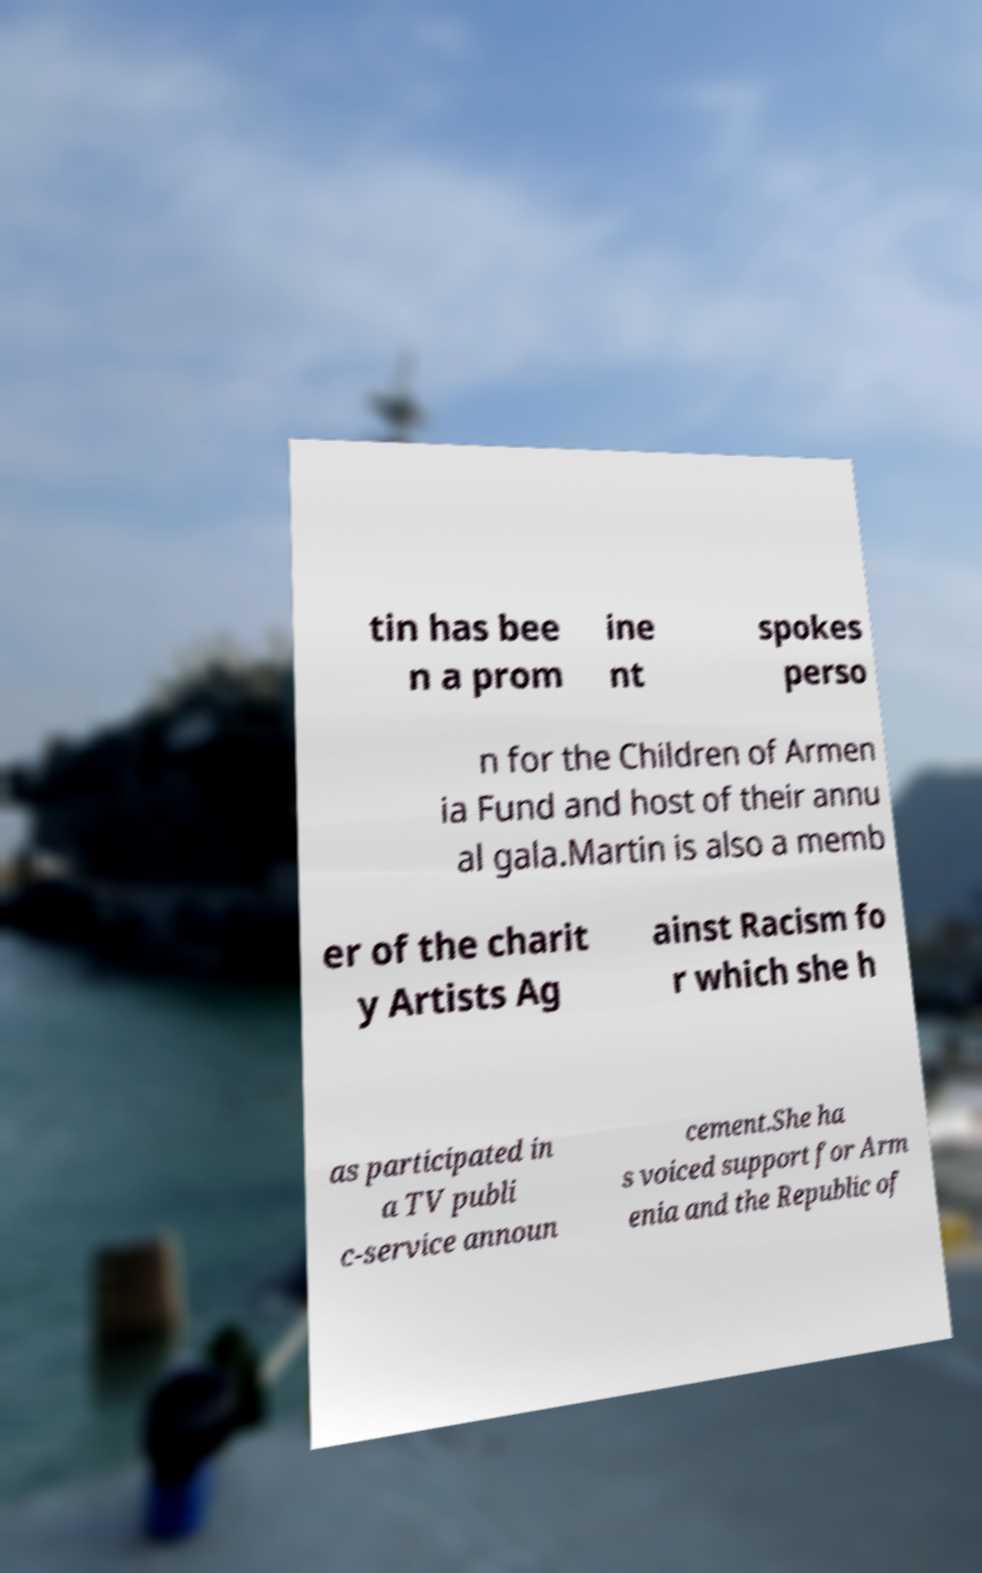Please read and relay the text visible in this image. What does it say? tin has bee n a prom ine nt spokes perso n for the Children of Armen ia Fund and host of their annu al gala.Martin is also a memb er of the charit y Artists Ag ainst Racism fo r which she h as participated in a TV publi c-service announ cement.She ha s voiced support for Arm enia and the Republic of 